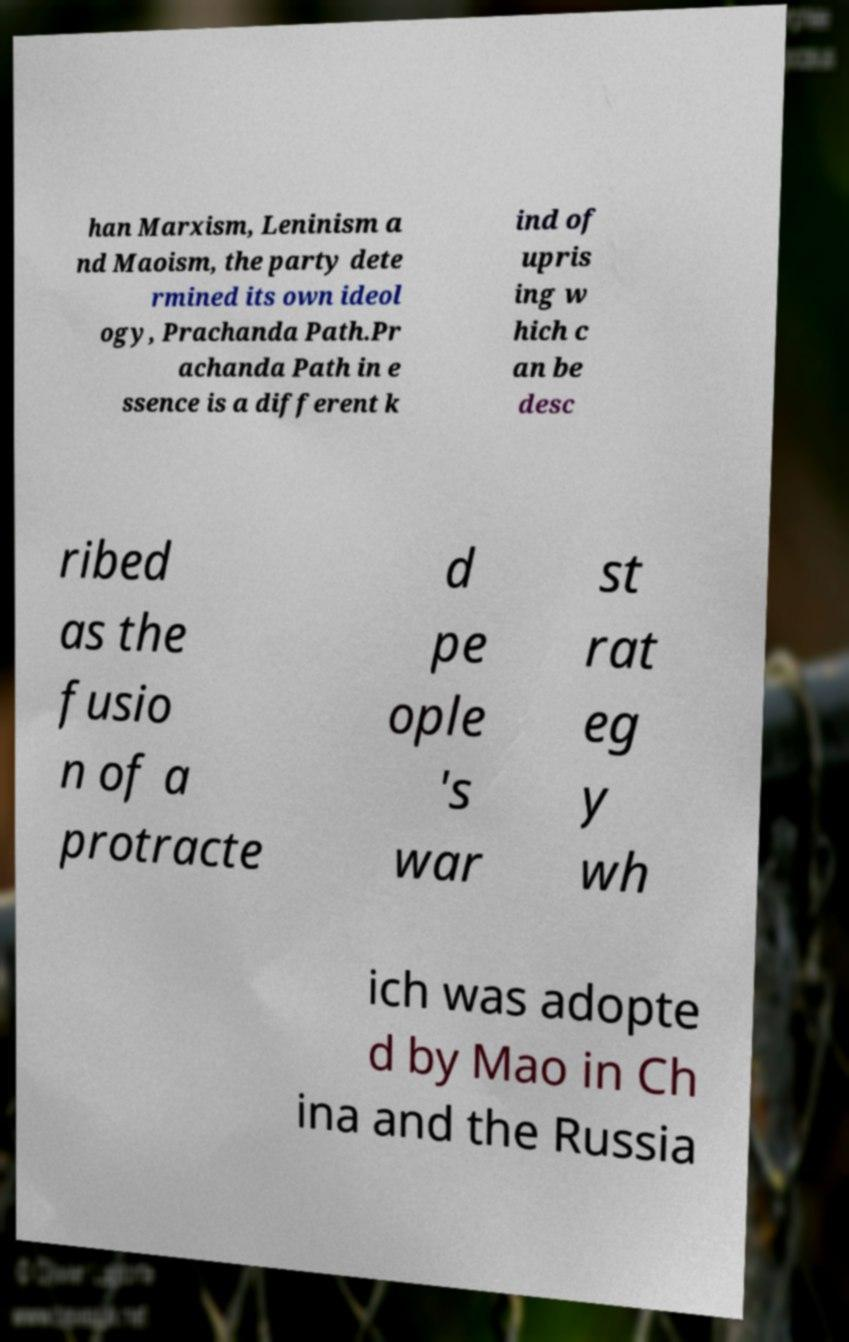Can you accurately transcribe the text from the provided image for me? han Marxism, Leninism a nd Maoism, the party dete rmined its own ideol ogy, Prachanda Path.Pr achanda Path in e ssence is a different k ind of upris ing w hich c an be desc ribed as the fusio n of a protracte d pe ople 's war st rat eg y wh ich was adopte d by Mao in Ch ina and the Russia 